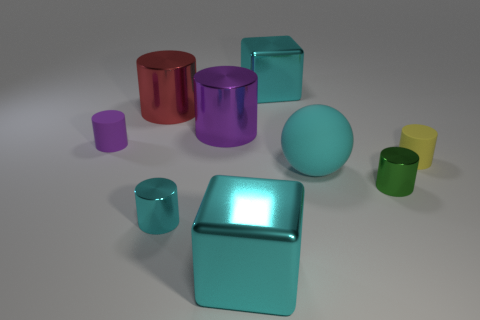There is a small purple thing that is the same shape as the yellow thing; what material is it?
Give a very brief answer. Rubber. There is a cylinder that is both behind the tiny green cylinder and in front of the purple matte cylinder; what material is it made of?
Make the answer very short. Rubber. Is the number of purple rubber cylinders that are right of the ball less than the number of shiny cylinders behind the yellow cylinder?
Your response must be concise. Yes. How many other things are there of the same size as the matte sphere?
Provide a short and direct response. 4. What shape is the big cyan metallic object that is behind the small matte cylinder that is to the right of the metal block behind the tiny green shiny cylinder?
Your response must be concise. Cube. What number of blue things are small matte cylinders or tiny metal cylinders?
Your response must be concise. 0. There is a big cyan block that is in front of the small cyan shiny thing; how many large cyan spheres are to the right of it?
Provide a succinct answer. 1. Is there any other thing that has the same color as the large sphere?
Provide a short and direct response. Yes. There is a large thing that is made of the same material as the small yellow object; what is its shape?
Make the answer very short. Sphere. Do the big ball to the left of the small green cylinder and the purple cylinder behind the purple matte cylinder have the same material?
Ensure brevity in your answer.  No. 